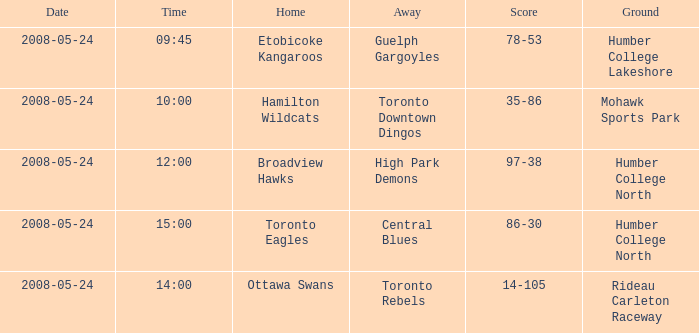On what grounds did the away team of the Toronto Rebels play? Rideau Carleton Raceway. 